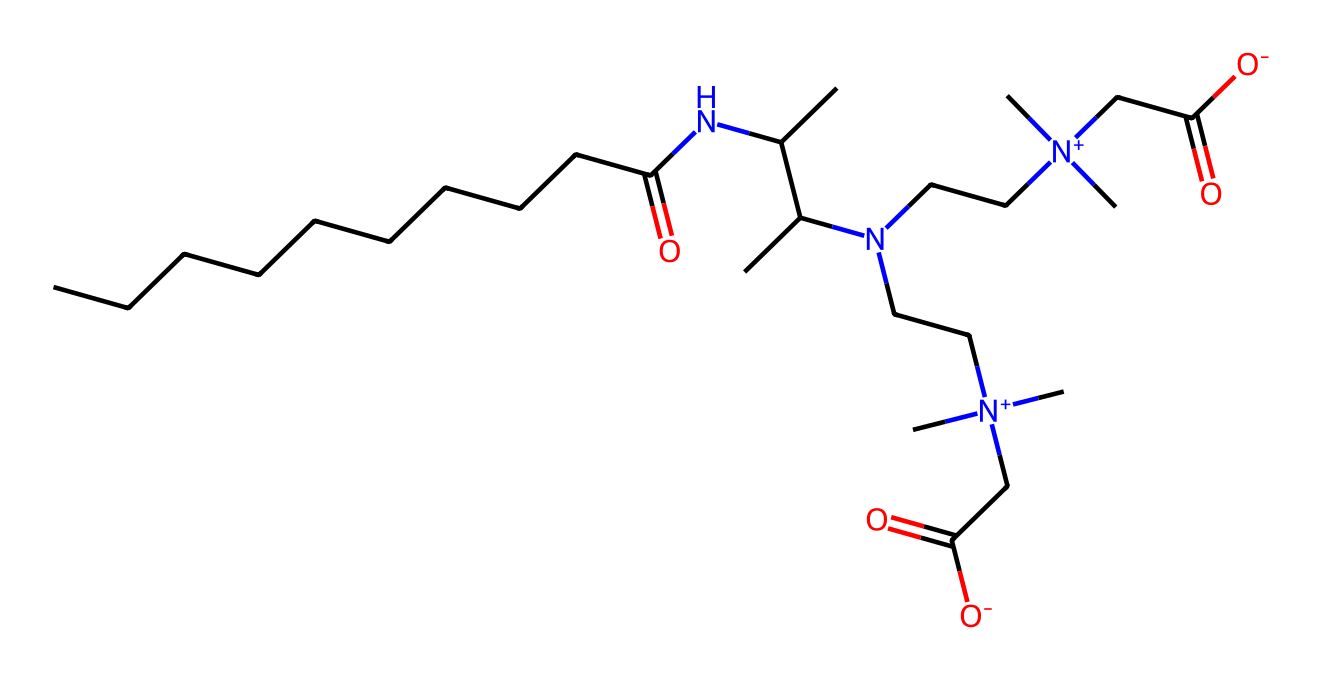What is the molecular formula of cocamidopropyl betaine? By interpreting the SMILES representation, we count the different atoms present in the structure: carbon (C), hydrogen (H), oxygen (O), and nitrogen (N) atoms, leading to the determination of the molecular formula.
Answer: C21H42N2O4 How many nitrogen atoms are present in cocamidopropyl betaine? Looking at the structure represented by the SMILES notation, we identify two nitrogen (N) atoms incorporated into the chemical makeup.
Answer: 2 Which functional groups are present in cocamidopropyl betaine? Analyzing the SMILES, we can identify amine groups (due to nitrogen atoms bonded to hydrogen), carboxylate groups (from the presence of a carboxylic acid), and possibly a quaternary amine structure, indicating the functional groups present in this molecule.
Answer: amine, carboxylate What is the primary purpose of cocamidopropyl betaine in personal care products? Based on the chemical properties and structure of cocamidopropyl betaine, it primarily serves as a surfactant and foam booster in personal care formulations, enhancing cleansing and foaming properties.
Answer: surfactant Is cocamidopropyl betaine considered anionic or cationic in nature? By examining the structure, especially the nitrogen's quaternary ammonium state, we deduce that cocamidopropyl betaine has both cationic characteristics (due to the positively charged nitrogen) and anionic characteristics (from the carboxylate), but is primarily classified as amphoteric.
Answer: amphoteric How many carbon atoms are in the hydrophobic tail of cocamidopropyl betaine? Reviewing the SMILES structure, we count the carbon atoms in the long aliphatic chain, specifically from the fatty acid part, which consists of ten carbon atoms in the tail.
Answer: 10 